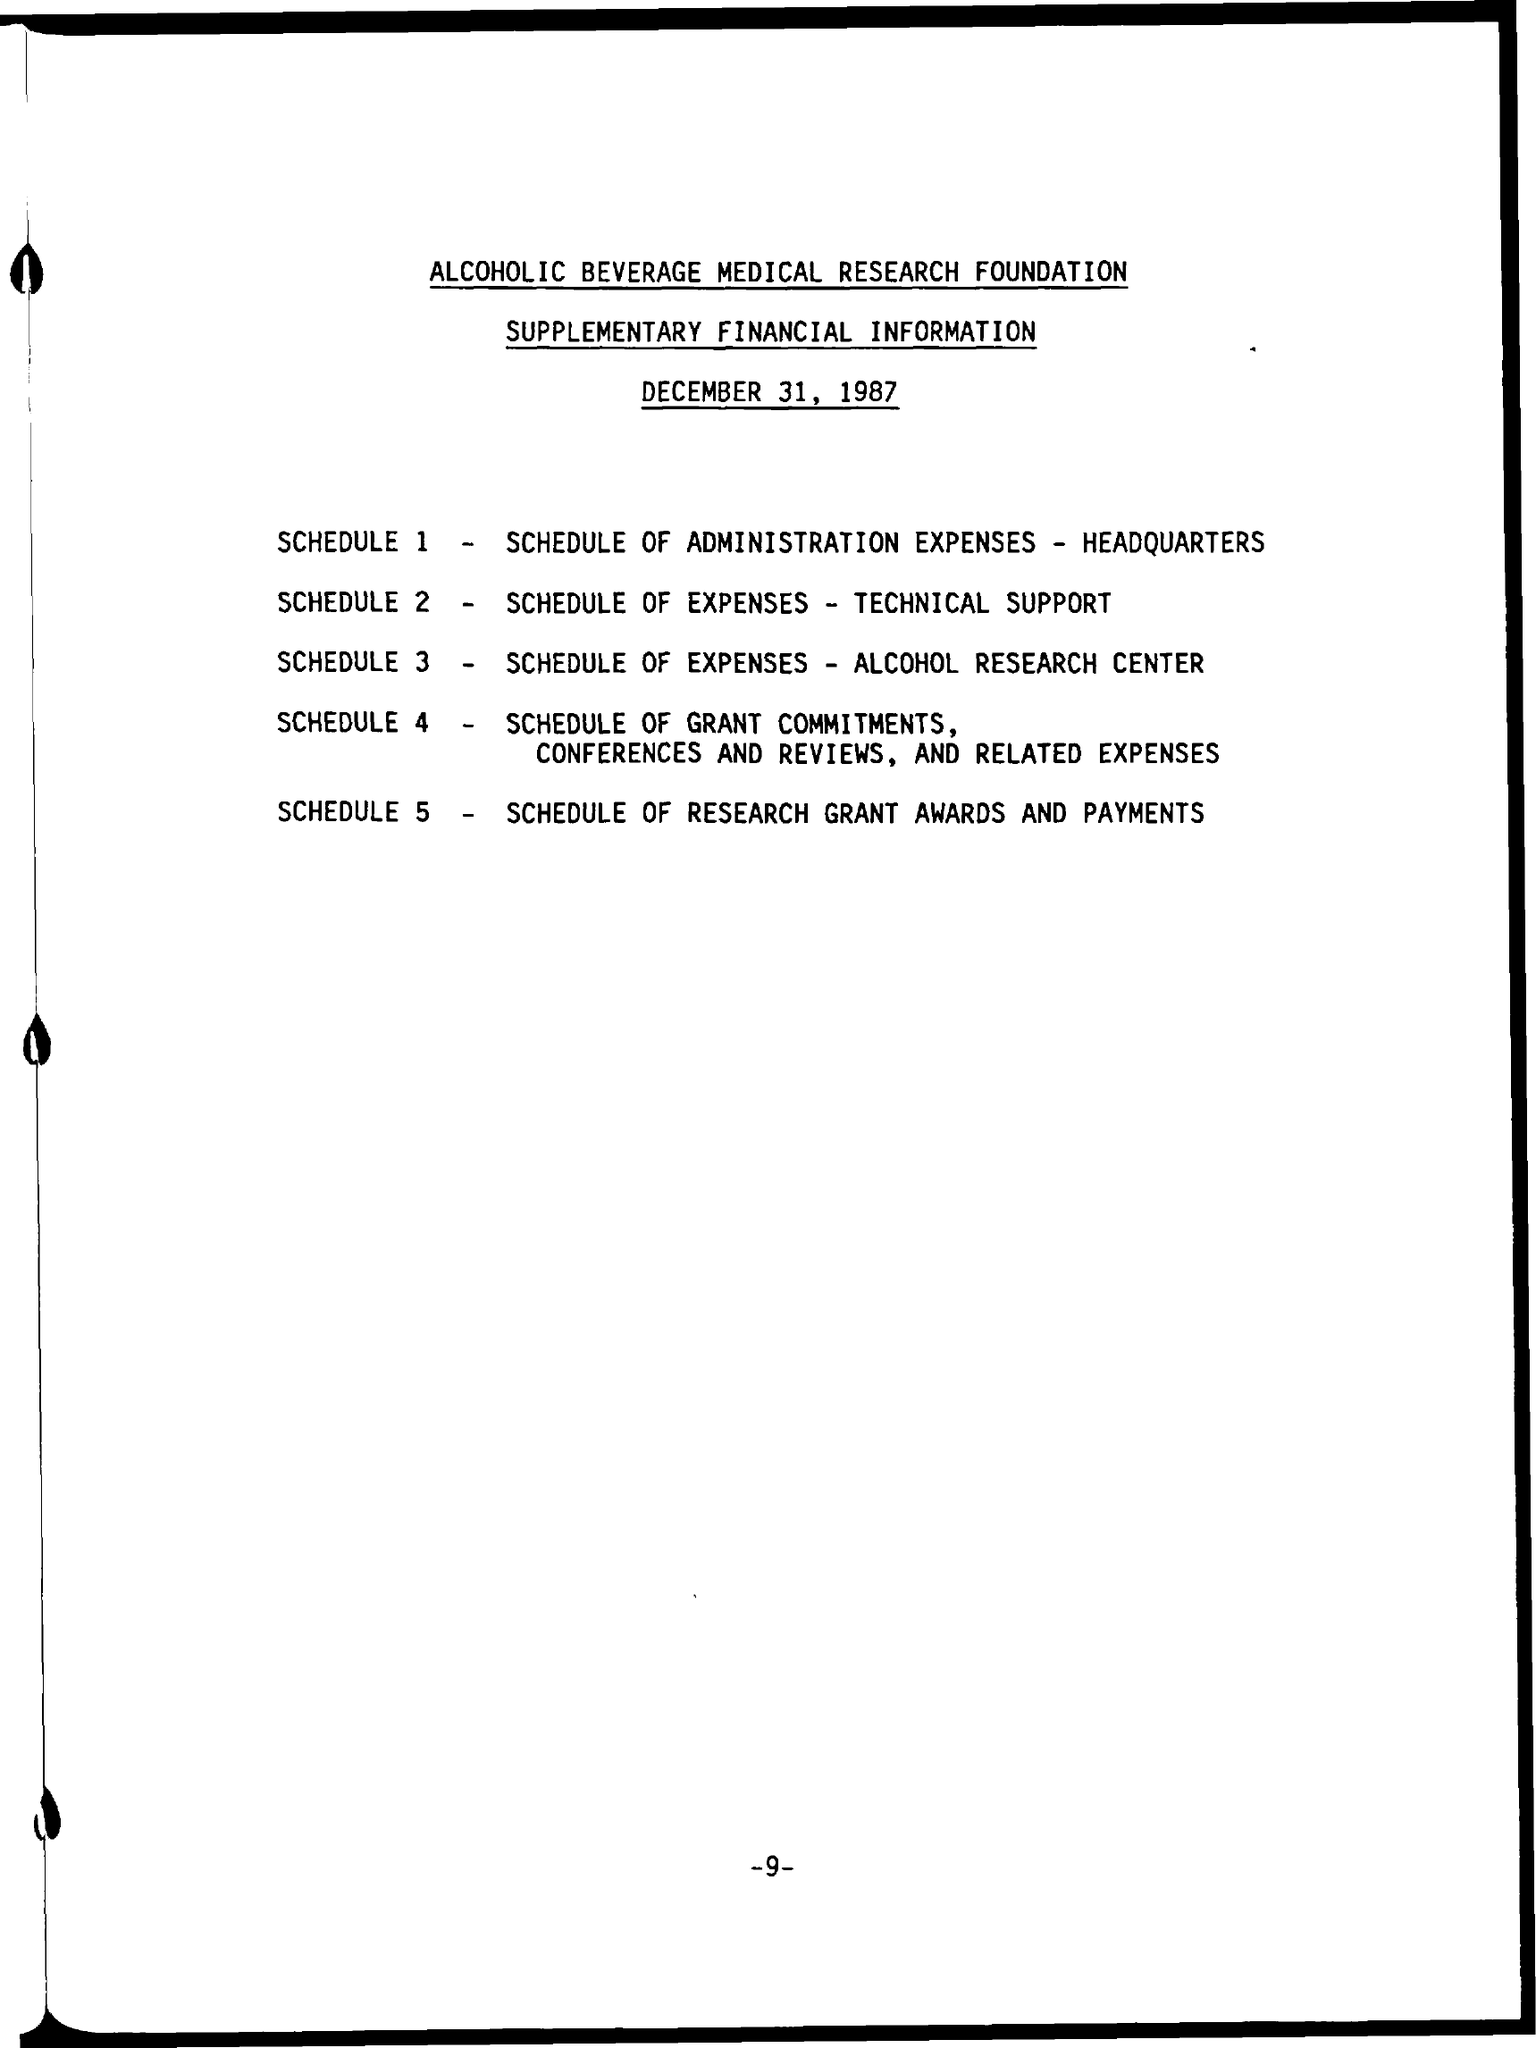List a handful of essential elements in this visual. The schedule 3 refers to the schedule of expenses for the Alcohol Research Center. The document is titled "SCHEDULE 2: SCHEDULE OF EXPENSES - TECHNICAL SUPPORT" and provides details of the technical support expenses incurred during the relevant period. The Schedule 5 outlines the details of the research grant, awards, and payments. 